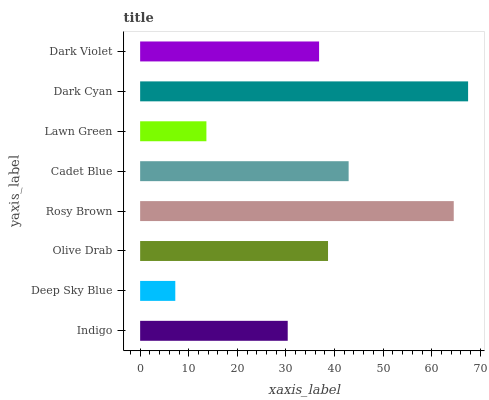Is Deep Sky Blue the minimum?
Answer yes or no. Yes. Is Dark Cyan the maximum?
Answer yes or no. Yes. Is Olive Drab the minimum?
Answer yes or no. No. Is Olive Drab the maximum?
Answer yes or no. No. Is Olive Drab greater than Deep Sky Blue?
Answer yes or no. Yes. Is Deep Sky Blue less than Olive Drab?
Answer yes or no. Yes. Is Deep Sky Blue greater than Olive Drab?
Answer yes or no. No. Is Olive Drab less than Deep Sky Blue?
Answer yes or no. No. Is Olive Drab the high median?
Answer yes or no. Yes. Is Dark Violet the low median?
Answer yes or no. Yes. Is Indigo the high median?
Answer yes or no. No. Is Olive Drab the low median?
Answer yes or no. No. 